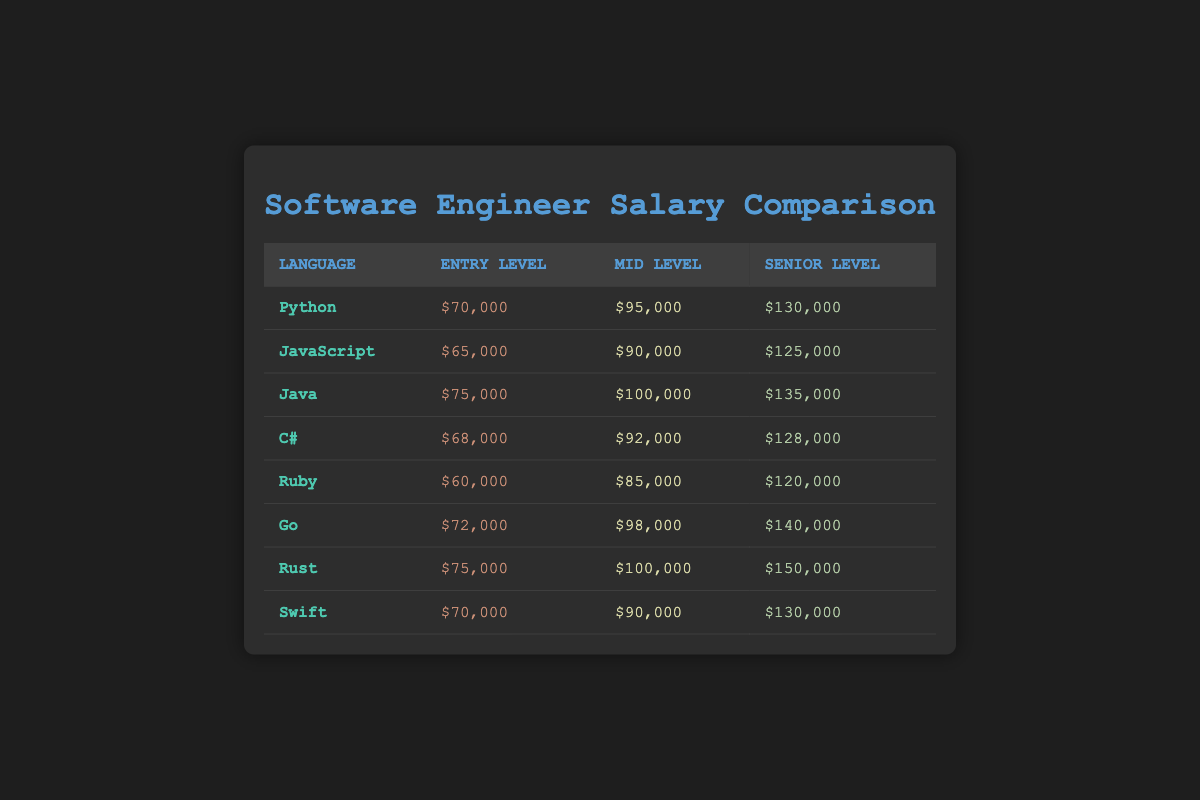What is the entry-level salary for a Rust programmer? The entry-level salary for Rust can be found in the table under the column "Entry Level" corresponding to Rust. It is listed as $75,000.
Answer: $75,000 Which programming language has the highest mid-level salary? By reviewing the table, the mid-level salaries for each programming language are compared. Go has a mid-level salary of $98,000, which is the highest among all the languages listed.
Answer: Go Is the entry-level salary for C# higher than that for Ruby? The entry-level salary for C# is $68,000, while the entry-level salary for Ruby is $60,000. Since $68,000 is greater than $60,000, the entry-level salary for C# is indeed higher than Ruby.
Answer: Yes What is the difference between the senior-level salary of Java and Python? To find the difference, the senior-level salaries for both languages are needed. Java's senior-level salary is $135,000 and Python's is $130,000. The difference is calculated as $135,000 - $130,000 = $5,000.
Answer: $5,000 What is the average entry-level salary for the languages listed? The entry-level salaries are $70,000 (Python), $65,000 (JavaScript), $75,000 (Java), $68,000 (C#), $60,000 (Ruby), $72,000 (Go), $75,000 (Rust), and $70,000 (Swift). Adding these gives a total of $70,000 + $65,000 + $75,000 + $68,000 + $60,000 + $72,000 + $75,000 + $70,000 = $585,000. There are 8 languages, so the average is $585,000 / 8 = $73,125.
Answer: $73,125 Does Swift have an entry-level salary that is equal to or greater than the entry-level salary for Java? The entry-level salary for Swift is $70,000, while for Java it is $75,000. Since $70,000 is less than $75,000, the entry-level salary for Swift is not equal to or greater than that for Java.
Answer: No 